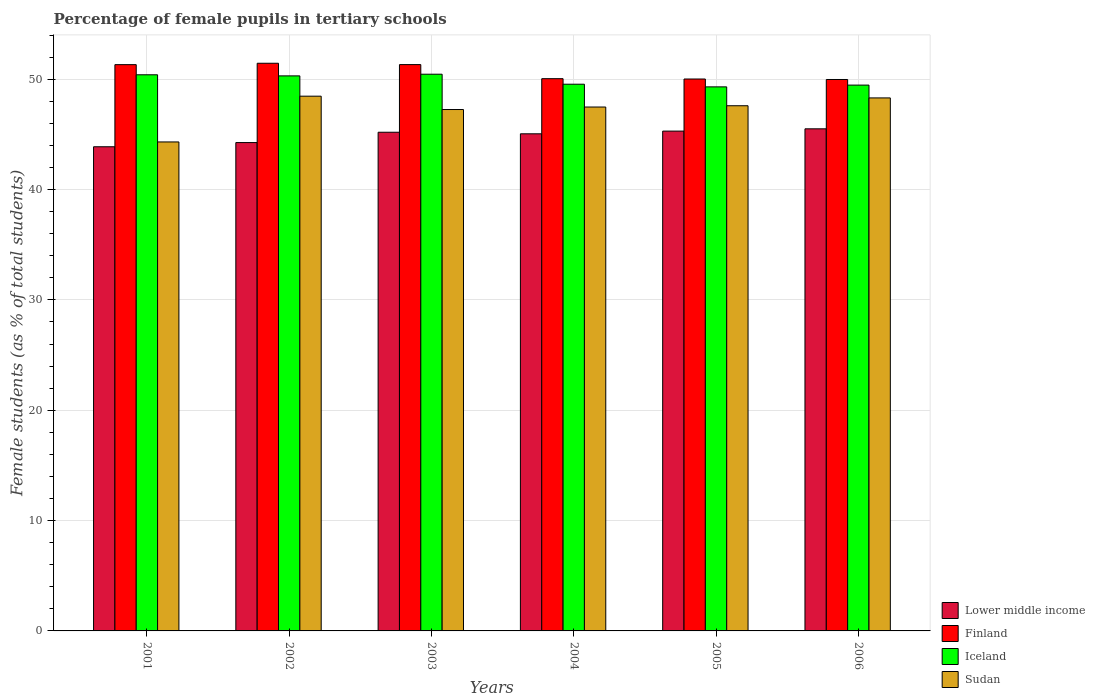How many different coloured bars are there?
Give a very brief answer. 4. How many groups of bars are there?
Offer a very short reply. 6. How many bars are there on the 1st tick from the right?
Make the answer very short. 4. What is the label of the 1st group of bars from the left?
Your answer should be compact. 2001. In how many cases, is the number of bars for a given year not equal to the number of legend labels?
Provide a short and direct response. 0. What is the percentage of female pupils in tertiary schools in Sudan in 2001?
Your answer should be compact. 44.31. Across all years, what is the maximum percentage of female pupils in tertiary schools in Lower middle income?
Ensure brevity in your answer.  45.5. Across all years, what is the minimum percentage of female pupils in tertiary schools in Finland?
Your answer should be very brief. 49.97. In which year was the percentage of female pupils in tertiary schools in Finland maximum?
Your response must be concise. 2002. In which year was the percentage of female pupils in tertiary schools in Lower middle income minimum?
Offer a very short reply. 2001. What is the total percentage of female pupils in tertiary schools in Iceland in the graph?
Provide a succinct answer. 299.46. What is the difference between the percentage of female pupils in tertiary schools in Finland in 2005 and that in 2006?
Give a very brief answer. 0.04. What is the difference between the percentage of female pupils in tertiary schools in Sudan in 2003 and the percentage of female pupils in tertiary schools in Lower middle income in 2005?
Make the answer very short. 1.96. What is the average percentage of female pupils in tertiary schools in Finland per year?
Your answer should be very brief. 50.69. In the year 2004, what is the difference between the percentage of female pupils in tertiary schools in Iceland and percentage of female pupils in tertiary schools in Lower middle income?
Provide a short and direct response. 4.5. In how many years, is the percentage of female pupils in tertiary schools in Sudan greater than 32 %?
Give a very brief answer. 6. What is the ratio of the percentage of female pupils in tertiary schools in Iceland in 2001 to that in 2006?
Ensure brevity in your answer.  1.02. Is the percentage of female pupils in tertiary schools in Iceland in 2001 less than that in 2004?
Provide a succinct answer. No. What is the difference between the highest and the second highest percentage of female pupils in tertiary schools in Lower middle income?
Provide a succinct answer. 0.21. What is the difference between the highest and the lowest percentage of female pupils in tertiary schools in Sudan?
Keep it short and to the point. 4.15. Is the sum of the percentage of female pupils in tertiary schools in Iceland in 2002 and 2004 greater than the maximum percentage of female pupils in tertiary schools in Finland across all years?
Your answer should be very brief. Yes. Is it the case that in every year, the sum of the percentage of female pupils in tertiary schools in Iceland and percentage of female pupils in tertiary schools in Sudan is greater than the sum of percentage of female pupils in tertiary schools in Lower middle income and percentage of female pupils in tertiary schools in Finland?
Provide a succinct answer. Yes. What does the 3rd bar from the left in 2003 represents?
Your answer should be very brief. Iceland. Are all the bars in the graph horizontal?
Give a very brief answer. No. How many years are there in the graph?
Offer a very short reply. 6. What is the difference between two consecutive major ticks on the Y-axis?
Offer a very short reply. 10. Does the graph contain any zero values?
Make the answer very short. No. Where does the legend appear in the graph?
Provide a succinct answer. Bottom right. How many legend labels are there?
Make the answer very short. 4. How are the legend labels stacked?
Make the answer very short. Vertical. What is the title of the graph?
Your answer should be very brief. Percentage of female pupils in tertiary schools. What is the label or title of the X-axis?
Your answer should be very brief. Years. What is the label or title of the Y-axis?
Provide a short and direct response. Female students (as % of total students). What is the Female students (as % of total students) of Lower middle income in 2001?
Your response must be concise. 43.87. What is the Female students (as % of total students) of Finland in 2001?
Ensure brevity in your answer.  51.32. What is the Female students (as % of total students) in Iceland in 2001?
Provide a short and direct response. 50.4. What is the Female students (as % of total students) in Sudan in 2001?
Provide a short and direct response. 44.31. What is the Female students (as % of total students) in Lower middle income in 2002?
Give a very brief answer. 44.25. What is the Female students (as % of total students) of Finland in 2002?
Provide a succinct answer. 51.44. What is the Female students (as % of total students) of Iceland in 2002?
Make the answer very short. 50.3. What is the Female students (as % of total students) in Sudan in 2002?
Your response must be concise. 48.46. What is the Female students (as % of total students) of Lower middle income in 2003?
Give a very brief answer. 45.19. What is the Female students (as % of total students) in Finland in 2003?
Give a very brief answer. 51.32. What is the Female students (as % of total students) of Iceland in 2003?
Provide a short and direct response. 50.45. What is the Female students (as % of total students) in Sudan in 2003?
Make the answer very short. 47.25. What is the Female students (as % of total students) of Lower middle income in 2004?
Provide a short and direct response. 45.05. What is the Female students (as % of total students) in Finland in 2004?
Provide a succinct answer. 50.04. What is the Female students (as % of total students) in Iceland in 2004?
Ensure brevity in your answer.  49.54. What is the Female students (as % of total students) in Sudan in 2004?
Keep it short and to the point. 47.48. What is the Female students (as % of total students) of Lower middle income in 2005?
Offer a very short reply. 45.29. What is the Female students (as % of total students) of Finland in 2005?
Offer a terse response. 50.02. What is the Female students (as % of total students) in Iceland in 2005?
Offer a very short reply. 49.3. What is the Female students (as % of total students) of Sudan in 2005?
Your answer should be very brief. 47.59. What is the Female students (as % of total students) in Lower middle income in 2006?
Your answer should be very brief. 45.5. What is the Female students (as % of total students) of Finland in 2006?
Ensure brevity in your answer.  49.97. What is the Female students (as % of total students) of Iceland in 2006?
Offer a terse response. 49.46. What is the Female students (as % of total students) of Sudan in 2006?
Your answer should be very brief. 48.3. Across all years, what is the maximum Female students (as % of total students) of Lower middle income?
Provide a short and direct response. 45.5. Across all years, what is the maximum Female students (as % of total students) in Finland?
Your response must be concise. 51.44. Across all years, what is the maximum Female students (as % of total students) of Iceland?
Provide a succinct answer. 50.45. Across all years, what is the maximum Female students (as % of total students) in Sudan?
Make the answer very short. 48.46. Across all years, what is the minimum Female students (as % of total students) of Lower middle income?
Ensure brevity in your answer.  43.87. Across all years, what is the minimum Female students (as % of total students) in Finland?
Ensure brevity in your answer.  49.97. Across all years, what is the minimum Female students (as % of total students) in Iceland?
Provide a short and direct response. 49.3. Across all years, what is the minimum Female students (as % of total students) in Sudan?
Offer a terse response. 44.31. What is the total Female students (as % of total students) in Lower middle income in the graph?
Your response must be concise. 269.17. What is the total Female students (as % of total students) of Finland in the graph?
Your answer should be very brief. 304.11. What is the total Female students (as % of total students) in Iceland in the graph?
Your response must be concise. 299.46. What is the total Female students (as % of total students) in Sudan in the graph?
Provide a short and direct response. 283.39. What is the difference between the Female students (as % of total students) in Lower middle income in 2001 and that in 2002?
Provide a succinct answer. -0.38. What is the difference between the Female students (as % of total students) of Finland in 2001 and that in 2002?
Provide a short and direct response. -0.13. What is the difference between the Female students (as % of total students) of Iceland in 2001 and that in 2002?
Ensure brevity in your answer.  0.1. What is the difference between the Female students (as % of total students) of Sudan in 2001 and that in 2002?
Ensure brevity in your answer.  -4.15. What is the difference between the Female students (as % of total students) of Lower middle income in 2001 and that in 2003?
Your answer should be very brief. -1.32. What is the difference between the Female students (as % of total students) in Finland in 2001 and that in 2003?
Your response must be concise. -0.01. What is the difference between the Female students (as % of total students) of Iceland in 2001 and that in 2003?
Ensure brevity in your answer.  -0.05. What is the difference between the Female students (as % of total students) in Sudan in 2001 and that in 2003?
Make the answer very short. -2.94. What is the difference between the Female students (as % of total students) in Lower middle income in 2001 and that in 2004?
Make the answer very short. -1.17. What is the difference between the Female students (as % of total students) in Finland in 2001 and that in 2004?
Your answer should be compact. 1.27. What is the difference between the Female students (as % of total students) in Iceland in 2001 and that in 2004?
Make the answer very short. 0.85. What is the difference between the Female students (as % of total students) of Sudan in 2001 and that in 2004?
Provide a short and direct response. -3.16. What is the difference between the Female students (as % of total students) in Lower middle income in 2001 and that in 2005?
Make the answer very short. -1.42. What is the difference between the Female students (as % of total students) in Finland in 2001 and that in 2005?
Offer a terse response. 1.3. What is the difference between the Female students (as % of total students) of Iceland in 2001 and that in 2005?
Offer a terse response. 1.1. What is the difference between the Female students (as % of total students) of Sudan in 2001 and that in 2005?
Ensure brevity in your answer.  -3.28. What is the difference between the Female students (as % of total students) of Lower middle income in 2001 and that in 2006?
Ensure brevity in your answer.  -1.63. What is the difference between the Female students (as % of total students) of Finland in 2001 and that in 2006?
Provide a short and direct response. 1.34. What is the difference between the Female students (as % of total students) of Iceland in 2001 and that in 2006?
Give a very brief answer. 0.93. What is the difference between the Female students (as % of total students) in Sudan in 2001 and that in 2006?
Provide a succinct answer. -3.99. What is the difference between the Female students (as % of total students) of Lower middle income in 2002 and that in 2003?
Keep it short and to the point. -0.94. What is the difference between the Female students (as % of total students) of Finland in 2002 and that in 2003?
Your answer should be very brief. 0.12. What is the difference between the Female students (as % of total students) in Iceland in 2002 and that in 2003?
Ensure brevity in your answer.  -0.15. What is the difference between the Female students (as % of total students) of Sudan in 2002 and that in 2003?
Your response must be concise. 1.21. What is the difference between the Female students (as % of total students) of Lower middle income in 2002 and that in 2004?
Ensure brevity in your answer.  -0.79. What is the difference between the Female students (as % of total students) of Finland in 2002 and that in 2004?
Offer a terse response. 1.4. What is the difference between the Female students (as % of total students) of Iceland in 2002 and that in 2004?
Provide a succinct answer. 0.75. What is the difference between the Female students (as % of total students) of Sudan in 2002 and that in 2004?
Provide a short and direct response. 0.98. What is the difference between the Female students (as % of total students) in Lower middle income in 2002 and that in 2005?
Offer a very short reply. -1.04. What is the difference between the Female students (as % of total students) of Finland in 2002 and that in 2005?
Give a very brief answer. 1.43. What is the difference between the Female students (as % of total students) in Sudan in 2002 and that in 2005?
Keep it short and to the point. 0.87. What is the difference between the Female students (as % of total students) in Lower middle income in 2002 and that in 2006?
Ensure brevity in your answer.  -1.25. What is the difference between the Female students (as % of total students) in Finland in 2002 and that in 2006?
Provide a short and direct response. 1.47. What is the difference between the Female students (as % of total students) of Iceland in 2002 and that in 2006?
Your response must be concise. 0.84. What is the difference between the Female students (as % of total students) in Sudan in 2002 and that in 2006?
Make the answer very short. 0.16. What is the difference between the Female students (as % of total students) in Lower middle income in 2003 and that in 2004?
Give a very brief answer. 0.14. What is the difference between the Female students (as % of total students) of Finland in 2003 and that in 2004?
Make the answer very short. 1.28. What is the difference between the Female students (as % of total students) in Iceland in 2003 and that in 2004?
Ensure brevity in your answer.  0.91. What is the difference between the Female students (as % of total students) of Sudan in 2003 and that in 2004?
Keep it short and to the point. -0.23. What is the difference between the Female students (as % of total students) in Lower middle income in 2003 and that in 2005?
Ensure brevity in your answer.  -0.1. What is the difference between the Female students (as % of total students) in Finland in 2003 and that in 2005?
Your answer should be compact. 1.31. What is the difference between the Female students (as % of total students) of Iceland in 2003 and that in 2005?
Give a very brief answer. 1.15. What is the difference between the Female students (as % of total students) in Sudan in 2003 and that in 2005?
Offer a terse response. -0.34. What is the difference between the Female students (as % of total students) of Lower middle income in 2003 and that in 2006?
Your response must be concise. -0.31. What is the difference between the Female students (as % of total students) in Finland in 2003 and that in 2006?
Give a very brief answer. 1.35. What is the difference between the Female students (as % of total students) of Iceland in 2003 and that in 2006?
Ensure brevity in your answer.  0.99. What is the difference between the Female students (as % of total students) in Sudan in 2003 and that in 2006?
Provide a succinct answer. -1.05. What is the difference between the Female students (as % of total students) of Lower middle income in 2004 and that in 2005?
Your answer should be compact. -0.25. What is the difference between the Female students (as % of total students) of Finland in 2004 and that in 2005?
Your answer should be very brief. 0.03. What is the difference between the Female students (as % of total students) in Iceland in 2004 and that in 2005?
Offer a very short reply. 0.24. What is the difference between the Female students (as % of total students) of Sudan in 2004 and that in 2005?
Offer a terse response. -0.12. What is the difference between the Female students (as % of total students) of Lower middle income in 2004 and that in 2006?
Offer a terse response. -0.45. What is the difference between the Female students (as % of total students) in Finland in 2004 and that in 2006?
Your answer should be very brief. 0.07. What is the difference between the Female students (as % of total students) of Iceland in 2004 and that in 2006?
Provide a short and direct response. 0.08. What is the difference between the Female students (as % of total students) of Sudan in 2004 and that in 2006?
Your answer should be very brief. -0.83. What is the difference between the Female students (as % of total students) in Lower middle income in 2005 and that in 2006?
Your answer should be very brief. -0.21. What is the difference between the Female students (as % of total students) in Finland in 2005 and that in 2006?
Your answer should be compact. 0.04. What is the difference between the Female students (as % of total students) in Iceland in 2005 and that in 2006?
Your answer should be compact. -0.16. What is the difference between the Female students (as % of total students) in Sudan in 2005 and that in 2006?
Make the answer very short. -0.71. What is the difference between the Female students (as % of total students) of Lower middle income in 2001 and the Female students (as % of total students) of Finland in 2002?
Give a very brief answer. -7.57. What is the difference between the Female students (as % of total students) of Lower middle income in 2001 and the Female students (as % of total students) of Iceland in 2002?
Provide a short and direct response. -6.42. What is the difference between the Female students (as % of total students) of Lower middle income in 2001 and the Female students (as % of total students) of Sudan in 2002?
Provide a short and direct response. -4.58. What is the difference between the Female students (as % of total students) in Finland in 2001 and the Female students (as % of total students) in Iceland in 2002?
Make the answer very short. 1.02. What is the difference between the Female students (as % of total students) of Finland in 2001 and the Female students (as % of total students) of Sudan in 2002?
Your answer should be very brief. 2.86. What is the difference between the Female students (as % of total students) in Iceland in 2001 and the Female students (as % of total students) in Sudan in 2002?
Your answer should be compact. 1.94. What is the difference between the Female students (as % of total students) in Lower middle income in 2001 and the Female students (as % of total students) in Finland in 2003?
Ensure brevity in your answer.  -7.45. What is the difference between the Female students (as % of total students) of Lower middle income in 2001 and the Female students (as % of total students) of Iceland in 2003?
Give a very brief answer. -6.57. What is the difference between the Female students (as % of total students) in Lower middle income in 2001 and the Female students (as % of total students) in Sudan in 2003?
Provide a succinct answer. -3.37. What is the difference between the Female students (as % of total students) in Finland in 2001 and the Female students (as % of total students) in Iceland in 2003?
Ensure brevity in your answer.  0.87. What is the difference between the Female students (as % of total students) in Finland in 2001 and the Female students (as % of total students) in Sudan in 2003?
Offer a very short reply. 4.07. What is the difference between the Female students (as % of total students) in Iceland in 2001 and the Female students (as % of total students) in Sudan in 2003?
Your answer should be compact. 3.15. What is the difference between the Female students (as % of total students) in Lower middle income in 2001 and the Female students (as % of total students) in Finland in 2004?
Provide a short and direct response. -6.17. What is the difference between the Female students (as % of total students) of Lower middle income in 2001 and the Female students (as % of total students) of Iceland in 2004?
Your response must be concise. -5.67. What is the difference between the Female students (as % of total students) in Lower middle income in 2001 and the Female students (as % of total students) in Sudan in 2004?
Your answer should be compact. -3.6. What is the difference between the Female students (as % of total students) of Finland in 2001 and the Female students (as % of total students) of Iceland in 2004?
Keep it short and to the point. 1.77. What is the difference between the Female students (as % of total students) in Finland in 2001 and the Female students (as % of total students) in Sudan in 2004?
Keep it short and to the point. 3.84. What is the difference between the Female students (as % of total students) of Iceland in 2001 and the Female students (as % of total students) of Sudan in 2004?
Your response must be concise. 2.92. What is the difference between the Female students (as % of total students) in Lower middle income in 2001 and the Female students (as % of total students) in Finland in 2005?
Offer a very short reply. -6.14. What is the difference between the Female students (as % of total students) in Lower middle income in 2001 and the Female students (as % of total students) in Iceland in 2005?
Keep it short and to the point. -5.43. What is the difference between the Female students (as % of total students) of Lower middle income in 2001 and the Female students (as % of total students) of Sudan in 2005?
Provide a short and direct response. -3.72. What is the difference between the Female students (as % of total students) of Finland in 2001 and the Female students (as % of total students) of Iceland in 2005?
Provide a succinct answer. 2.01. What is the difference between the Female students (as % of total students) in Finland in 2001 and the Female students (as % of total students) in Sudan in 2005?
Ensure brevity in your answer.  3.72. What is the difference between the Female students (as % of total students) of Iceland in 2001 and the Female students (as % of total students) of Sudan in 2005?
Ensure brevity in your answer.  2.81. What is the difference between the Female students (as % of total students) in Lower middle income in 2001 and the Female students (as % of total students) in Finland in 2006?
Offer a very short reply. -6.1. What is the difference between the Female students (as % of total students) in Lower middle income in 2001 and the Female students (as % of total students) in Iceland in 2006?
Ensure brevity in your answer.  -5.59. What is the difference between the Female students (as % of total students) of Lower middle income in 2001 and the Female students (as % of total students) of Sudan in 2006?
Make the answer very short. -4.43. What is the difference between the Female students (as % of total students) of Finland in 2001 and the Female students (as % of total students) of Iceland in 2006?
Your answer should be compact. 1.85. What is the difference between the Female students (as % of total students) of Finland in 2001 and the Female students (as % of total students) of Sudan in 2006?
Your answer should be very brief. 3.01. What is the difference between the Female students (as % of total students) in Iceland in 2001 and the Female students (as % of total students) in Sudan in 2006?
Your response must be concise. 2.1. What is the difference between the Female students (as % of total students) of Lower middle income in 2002 and the Female students (as % of total students) of Finland in 2003?
Make the answer very short. -7.07. What is the difference between the Female students (as % of total students) in Lower middle income in 2002 and the Female students (as % of total students) in Iceland in 2003?
Provide a short and direct response. -6.19. What is the difference between the Female students (as % of total students) in Lower middle income in 2002 and the Female students (as % of total students) in Sudan in 2003?
Give a very brief answer. -2.99. What is the difference between the Female students (as % of total students) of Finland in 2002 and the Female students (as % of total students) of Sudan in 2003?
Ensure brevity in your answer.  4.19. What is the difference between the Female students (as % of total students) in Iceland in 2002 and the Female students (as % of total students) in Sudan in 2003?
Your answer should be very brief. 3.05. What is the difference between the Female students (as % of total students) of Lower middle income in 2002 and the Female students (as % of total students) of Finland in 2004?
Give a very brief answer. -5.79. What is the difference between the Female students (as % of total students) of Lower middle income in 2002 and the Female students (as % of total students) of Iceland in 2004?
Offer a terse response. -5.29. What is the difference between the Female students (as % of total students) in Lower middle income in 2002 and the Female students (as % of total students) in Sudan in 2004?
Provide a short and direct response. -3.22. What is the difference between the Female students (as % of total students) in Finland in 2002 and the Female students (as % of total students) in Iceland in 2004?
Provide a succinct answer. 1.9. What is the difference between the Female students (as % of total students) in Finland in 2002 and the Female students (as % of total students) in Sudan in 2004?
Provide a succinct answer. 3.97. What is the difference between the Female students (as % of total students) of Iceland in 2002 and the Female students (as % of total students) of Sudan in 2004?
Offer a very short reply. 2.82. What is the difference between the Female students (as % of total students) of Lower middle income in 2002 and the Female students (as % of total students) of Finland in 2005?
Your answer should be compact. -5.76. What is the difference between the Female students (as % of total students) of Lower middle income in 2002 and the Female students (as % of total students) of Iceland in 2005?
Offer a very short reply. -5.05. What is the difference between the Female students (as % of total students) of Lower middle income in 2002 and the Female students (as % of total students) of Sudan in 2005?
Provide a succinct answer. -3.34. What is the difference between the Female students (as % of total students) of Finland in 2002 and the Female students (as % of total students) of Iceland in 2005?
Give a very brief answer. 2.14. What is the difference between the Female students (as % of total students) of Finland in 2002 and the Female students (as % of total students) of Sudan in 2005?
Your answer should be very brief. 3.85. What is the difference between the Female students (as % of total students) of Iceland in 2002 and the Female students (as % of total students) of Sudan in 2005?
Ensure brevity in your answer.  2.71. What is the difference between the Female students (as % of total students) of Lower middle income in 2002 and the Female students (as % of total students) of Finland in 2006?
Offer a terse response. -5.72. What is the difference between the Female students (as % of total students) of Lower middle income in 2002 and the Female students (as % of total students) of Iceland in 2006?
Provide a succinct answer. -5.21. What is the difference between the Female students (as % of total students) of Lower middle income in 2002 and the Female students (as % of total students) of Sudan in 2006?
Provide a short and direct response. -4.05. What is the difference between the Female students (as % of total students) in Finland in 2002 and the Female students (as % of total students) in Iceland in 2006?
Provide a short and direct response. 1.98. What is the difference between the Female students (as % of total students) in Finland in 2002 and the Female students (as % of total students) in Sudan in 2006?
Offer a terse response. 3.14. What is the difference between the Female students (as % of total students) of Iceland in 2002 and the Female students (as % of total students) of Sudan in 2006?
Offer a very short reply. 2. What is the difference between the Female students (as % of total students) in Lower middle income in 2003 and the Female students (as % of total students) in Finland in 2004?
Ensure brevity in your answer.  -4.85. What is the difference between the Female students (as % of total students) of Lower middle income in 2003 and the Female students (as % of total students) of Iceland in 2004?
Your answer should be very brief. -4.35. What is the difference between the Female students (as % of total students) in Lower middle income in 2003 and the Female students (as % of total students) in Sudan in 2004?
Ensure brevity in your answer.  -2.29. What is the difference between the Female students (as % of total students) in Finland in 2003 and the Female students (as % of total students) in Iceland in 2004?
Offer a terse response. 1.78. What is the difference between the Female students (as % of total students) of Finland in 2003 and the Female students (as % of total students) of Sudan in 2004?
Offer a terse response. 3.85. What is the difference between the Female students (as % of total students) of Iceland in 2003 and the Female students (as % of total students) of Sudan in 2004?
Offer a terse response. 2.97. What is the difference between the Female students (as % of total students) of Lower middle income in 2003 and the Female students (as % of total students) of Finland in 2005?
Keep it short and to the point. -4.82. What is the difference between the Female students (as % of total students) of Lower middle income in 2003 and the Female students (as % of total students) of Iceland in 2005?
Offer a terse response. -4.11. What is the difference between the Female students (as % of total students) in Lower middle income in 2003 and the Female students (as % of total students) in Sudan in 2005?
Your answer should be very brief. -2.4. What is the difference between the Female students (as % of total students) of Finland in 2003 and the Female students (as % of total students) of Iceland in 2005?
Ensure brevity in your answer.  2.02. What is the difference between the Female students (as % of total students) in Finland in 2003 and the Female students (as % of total students) in Sudan in 2005?
Your answer should be compact. 3.73. What is the difference between the Female students (as % of total students) of Iceland in 2003 and the Female students (as % of total students) of Sudan in 2005?
Keep it short and to the point. 2.86. What is the difference between the Female students (as % of total students) in Lower middle income in 2003 and the Female students (as % of total students) in Finland in 2006?
Ensure brevity in your answer.  -4.78. What is the difference between the Female students (as % of total students) of Lower middle income in 2003 and the Female students (as % of total students) of Iceland in 2006?
Provide a succinct answer. -4.27. What is the difference between the Female students (as % of total students) of Lower middle income in 2003 and the Female students (as % of total students) of Sudan in 2006?
Your response must be concise. -3.11. What is the difference between the Female students (as % of total students) in Finland in 2003 and the Female students (as % of total students) in Iceland in 2006?
Your answer should be compact. 1.86. What is the difference between the Female students (as % of total students) of Finland in 2003 and the Female students (as % of total students) of Sudan in 2006?
Offer a very short reply. 3.02. What is the difference between the Female students (as % of total students) of Iceland in 2003 and the Female students (as % of total students) of Sudan in 2006?
Your answer should be very brief. 2.15. What is the difference between the Female students (as % of total students) of Lower middle income in 2004 and the Female students (as % of total students) of Finland in 2005?
Keep it short and to the point. -4.97. What is the difference between the Female students (as % of total students) of Lower middle income in 2004 and the Female students (as % of total students) of Iceland in 2005?
Give a very brief answer. -4.25. What is the difference between the Female students (as % of total students) in Lower middle income in 2004 and the Female students (as % of total students) in Sudan in 2005?
Offer a terse response. -2.54. What is the difference between the Female students (as % of total students) in Finland in 2004 and the Female students (as % of total students) in Iceland in 2005?
Your response must be concise. 0.74. What is the difference between the Female students (as % of total students) in Finland in 2004 and the Female students (as % of total students) in Sudan in 2005?
Give a very brief answer. 2.45. What is the difference between the Female students (as % of total students) of Iceland in 2004 and the Female students (as % of total students) of Sudan in 2005?
Keep it short and to the point. 1.95. What is the difference between the Female students (as % of total students) of Lower middle income in 2004 and the Female students (as % of total students) of Finland in 2006?
Make the answer very short. -4.92. What is the difference between the Female students (as % of total students) in Lower middle income in 2004 and the Female students (as % of total students) in Iceland in 2006?
Your answer should be compact. -4.41. What is the difference between the Female students (as % of total students) in Lower middle income in 2004 and the Female students (as % of total students) in Sudan in 2006?
Your answer should be compact. -3.25. What is the difference between the Female students (as % of total students) of Finland in 2004 and the Female students (as % of total students) of Iceland in 2006?
Provide a short and direct response. 0.58. What is the difference between the Female students (as % of total students) in Finland in 2004 and the Female students (as % of total students) in Sudan in 2006?
Your answer should be compact. 1.74. What is the difference between the Female students (as % of total students) in Iceland in 2004 and the Female students (as % of total students) in Sudan in 2006?
Offer a very short reply. 1.24. What is the difference between the Female students (as % of total students) in Lower middle income in 2005 and the Female students (as % of total students) in Finland in 2006?
Give a very brief answer. -4.68. What is the difference between the Female students (as % of total students) in Lower middle income in 2005 and the Female students (as % of total students) in Iceland in 2006?
Ensure brevity in your answer.  -4.17. What is the difference between the Female students (as % of total students) of Lower middle income in 2005 and the Female students (as % of total students) of Sudan in 2006?
Offer a terse response. -3.01. What is the difference between the Female students (as % of total students) of Finland in 2005 and the Female students (as % of total students) of Iceland in 2006?
Your answer should be compact. 0.55. What is the difference between the Female students (as % of total students) in Finland in 2005 and the Female students (as % of total students) in Sudan in 2006?
Provide a succinct answer. 1.71. What is the average Female students (as % of total students) of Lower middle income per year?
Offer a very short reply. 44.86. What is the average Female students (as % of total students) of Finland per year?
Your response must be concise. 50.69. What is the average Female students (as % of total students) in Iceland per year?
Keep it short and to the point. 49.91. What is the average Female students (as % of total students) of Sudan per year?
Make the answer very short. 47.23. In the year 2001, what is the difference between the Female students (as % of total students) of Lower middle income and Female students (as % of total students) of Finland?
Your answer should be compact. -7.44. In the year 2001, what is the difference between the Female students (as % of total students) of Lower middle income and Female students (as % of total students) of Iceland?
Give a very brief answer. -6.52. In the year 2001, what is the difference between the Female students (as % of total students) of Lower middle income and Female students (as % of total students) of Sudan?
Provide a succinct answer. -0.44. In the year 2001, what is the difference between the Female students (as % of total students) of Finland and Female students (as % of total students) of Iceland?
Give a very brief answer. 0.92. In the year 2001, what is the difference between the Female students (as % of total students) of Finland and Female students (as % of total students) of Sudan?
Your answer should be very brief. 7. In the year 2001, what is the difference between the Female students (as % of total students) of Iceland and Female students (as % of total students) of Sudan?
Offer a terse response. 6.09. In the year 2002, what is the difference between the Female students (as % of total students) in Lower middle income and Female students (as % of total students) in Finland?
Keep it short and to the point. -7.19. In the year 2002, what is the difference between the Female students (as % of total students) in Lower middle income and Female students (as % of total students) in Iceland?
Your answer should be compact. -6.04. In the year 2002, what is the difference between the Female students (as % of total students) of Lower middle income and Female students (as % of total students) of Sudan?
Make the answer very short. -4.2. In the year 2002, what is the difference between the Female students (as % of total students) in Finland and Female students (as % of total students) in Iceland?
Provide a succinct answer. 1.14. In the year 2002, what is the difference between the Female students (as % of total students) in Finland and Female students (as % of total students) in Sudan?
Your response must be concise. 2.98. In the year 2002, what is the difference between the Female students (as % of total students) in Iceland and Female students (as % of total students) in Sudan?
Keep it short and to the point. 1.84. In the year 2003, what is the difference between the Female students (as % of total students) in Lower middle income and Female students (as % of total students) in Finland?
Provide a succinct answer. -6.13. In the year 2003, what is the difference between the Female students (as % of total students) of Lower middle income and Female students (as % of total students) of Iceland?
Give a very brief answer. -5.26. In the year 2003, what is the difference between the Female students (as % of total students) of Lower middle income and Female students (as % of total students) of Sudan?
Ensure brevity in your answer.  -2.06. In the year 2003, what is the difference between the Female students (as % of total students) in Finland and Female students (as % of total students) in Iceland?
Make the answer very short. 0.87. In the year 2003, what is the difference between the Female students (as % of total students) of Finland and Female students (as % of total students) of Sudan?
Your answer should be very brief. 4.07. In the year 2003, what is the difference between the Female students (as % of total students) in Iceland and Female students (as % of total students) in Sudan?
Offer a terse response. 3.2. In the year 2004, what is the difference between the Female students (as % of total students) in Lower middle income and Female students (as % of total students) in Finland?
Give a very brief answer. -5. In the year 2004, what is the difference between the Female students (as % of total students) of Lower middle income and Female students (as % of total students) of Iceland?
Ensure brevity in your answer.  -4.5. In the year 2004, what is the difference between the Female students (as % of total students) in Lower middle income and Female students (as % of total students) in Sudan?
Your answer should be compact. -2.43. In the year 2004, what is the difference between the Female students (as % of total students) of Finland and Female students (as % of total students) of Iceland?
Offer a very short reply. 0.5. In the year 2004, what is the difference between the Female students (as % of total students) of Finland and Female students (as % of total students) of Sudan?
Your response must be concise. 2.57. In the year 2004, what is the difference between the Female students (as % of total students) of Iceland and Female students (as % of total students) of Sudan?
Give a very brief answer. 2.07. In the year 2005, what is the difference between the Female students (as % of total students) of Lower middle income and Female students (as % of total students) of Finland?
Provide a short and direct response. -4.72. In the year 2005, what is the difference between the Female students (as % of total students) in Lower middle income and Female students (as % of total students) in Iceland?
Provide a succinct answer. -4.01. In the year 2005, what is the difference between the Female students (as % of total students) of Lower middle income and Female students (as % of total students) of Sudan?
Offer a very short reply. -2.3. In the year 2005, what is the difference between the Female students (as % of total students) of Finland and Female students (as % of total students) of Iceland?
Your answer should be compact. 0.71. In the year 2005, what is the difference between the Female students (as % of total students) of Finland and Female students (as % of total students) of Sudan?
Your response must be concise. 2.42. In the year 2005, what is the difference between the Female students (as % of total students) of Iceland and Female students (as % of total students) of Sudan?
Your answer should be very brief. 1.71. In the year 2006, what is the difference between the Female students (as % of total students) in Lower middle income and Female students (as % of total students) in Finland?
Your answer should be very brief. -4.47. In the year 2006, what is the difference between the Female students (as % of total students) in Lower middle income and Female students (as % of total students) in Iceland?
Offer a very short reply. -3.96. In the year 2006, what is the difference between the Female students (as % of total students) of Lower middle income and Female students (as % of total students) of Sudan?
Give a very brief answer. -2.8. In the year 2006, what is the difference between the Female students (as % of total students) in Finland and Female students (as % of total students) in Iceland?
Your response must be concise. 0.51. In the year 2006, what is the difference between the Female students (as % of total students) of Finland and Female students (as % of total students) of Sudan?
Your answer should be very brief. 1.67. In the year 2006, what is the difference between the Female students (as % of total students) of Iceland and Female students (as % of total students) of Sudan?
Make the answer very short. 1.16. What is the ratio of the Female students (as % of total students) in Sudan in 2001 to that in 2002?
Offer a very short reply. 0.91. What is the ratio of the Female students (as % of total students) in Lower middle income in 2001 to that in 2003?
Provide a short and direct response. 0.97. What is the ratio of the Female students (as % of total students) in Finland in 2001 to that in 2003?
Provide a succinct answer. 1. What is the ratio of the Female students (as % of total students) in Sudan in 2001 to that in 2003?
Your answer should be compact. 0.94. What is the ratio of the Female students (as % of total students) of Lower middle income in 2001 to that in 2004?
Your answer should be compact. 0.97. What is the ratio of the Female students (as % of total students) of Finland in 2001 to that in 2004?
Offer a terse response. 1.03. What is the ratio of the Female students (as % of total students) of Iceland in 2001 to that in 2004?
Make the answer very short. 1.02. What is the ratio of the Female students (as % of total students) of Sudan in 2001 to that in 2004?
Ensure brevity in your answer.  0.93. What is the ratio of the Female students (as % of total students) of Lower middle income in 2001 to that in 2005?
Offer a terse response. 0.97. What is the ratio of the Female students (as % of total students) of Finland in 2001 to that in 2005?
Offer a terse response. 1.03. What is the ratio of the Female students (as % of total students) in Iceland in 2001 to that in 2005?
Ensure brevity in your answer.  1.02. What is the ratio of the Female students (as % of total students) in Sudan in 2001 to that in 2005?
Keep it short and to the point. 0.93. What is the ratio of the Female students (as % of total students) of Finland in 2001 to that in 2006?
Keep it short and to the point. 1.03. What is the ratio of the Female students (as % of total students) in Iceland in 2001 to that in 2006?
Your answer should be compact. 1.02. What is the ratio of the Female students (as % of total students) in Sudan in 2001 to that in 2006?
Make the answer very short. 0.92. What is the ratio of the Female students (as % of total students) in Lower middle income in 2002 to that in 2003?
Your answer should be compact. 0.98. What is the ratio of the Female students (as % of total students) of Finland in 2002 to that in 2003?
Your response must be concise. 1. What is the ratio of the Female students (as % of total students) in Sudan in 2002 to that in 2003?
Your response must be concise. 1.03. What is the ratio of the Female students (as % of total students) of Lower middle income in 2002 to that in 2004?
Give a very brief answer. 0.98. What is the ratio of the Female students (as % of total students) in Finland in 2002 to that in 2004?
Provide a short and direct response. 1.03. What is the ratio of the Female students (as % of total students) of Iceland in 2002 to that in 2004?
Ensure brevity in your answer.  1.02. What is the ratio of the Female students (as % of total students) in Sudan in 2002 to that in 2004?
Make the answer very short. 1.02. What is the ratio of the Female students (as % of total students) in Finland in 2002 to that in 2005?
Make the answer very short. 1.03. What is the ratio of the Female students (as % of total students) of Iceland in 2002 to that in 2005?
Your answer should be compact. 1.02. What is the ratio of the Female students (as % of total students) in Sudan in 2002 to that in 2005?
Make the answer very short. 1.02. What is the ratio of the Female students (as % of total students) of Lower middle income in 2002 to that in 2006?
Your answer should be very brief. 0.97. What is the ratio of the Female students (as % of total students) in Finland in 2002 to that in 2006?
Your response must be concise. 1.03. What is the ratio of the Female students (as % of total students) in Iceland in 2002 to that in 2006?
Your response must be concise. 1.02. What is the ratio of the Female students (as % of total students) in Sudan in 2002 to that in 2006?
Keep it short and to the point. 1. What is the ratio of the Female students (as % of total students) in Finland in 2003 to that in 2004?
Give a very brief answer. 1.03. What is the ratio of the Female students (as % of total students) in Iceland in 2003 to that in 2004?
Your response must be concise. 1.02. What is the ratio of the Female students (as % of total students) of Sudan in 2003 to that in 2004?
Make the answer very short. 1. What is the ratio of the Female students (as % of total students) in Finland in 2003 to that in 2005?
Give a very brief answer. 1.03. What is the ratio of the Female students (as % of total students) in Iceland in 2003 to that in 2005?
Ensure brevity in your answer.  1.02. What is the ratio of the Female students (as % of total students) of Iceland in 2003 to that in 2006?
Your answer should be very brief. 1.02. What is the ratio of the Female students (as % of total students) of Sudan in 2003 to that in 2006?
Give a very brief answer. 0.98. What is the ratio of the Female students (as % of total students) of Lower middle income in 2004 to that in 2005?
Offer a terse response. 0.99. What is the ratio of the Female students (as % of total students) in Iceland in 2004 to that in 2005?
Keep it short and to the point. 1. What is the ratio of the Female students (as % of total students) in Sudan in 2004 to that in 2005?
Provide a succinct answer. 1. What is the ratio of the Female students (as % of total students) in Lower middle income in 2004 to that in 2006?
Your answer should be very brief. 0.99. What is the ratio of the Female students (as % of total students) of Finland in 2004 to that in 2006?
Make the answer very short. 1. What is the ratio of the Female students (as % of total students) in Iceland in 2004 to that in 2006?
Provide a succinct answer. 1. What is the ratio of the Female students (as % of total students) in Sudan in 2004 to that in 2006?
Your answer should be very brief. 0.98. What is the ratio of the Female students (as % of total students) in Lower middle income in 2005 to that in 2006?
Make the answer very short. 1. What is the ratio of the Female students (as % of total students) of Sudan in 2005 to that in 2006?
Offer a very short reply. 0.99. What is the difference between the highest and the second highest Female students (as % of total students) of Lower middle income?
Give a very brief answer. 0.21. What is the difference between the highest and the second highest Female students (as % of total students) in Finland?
Your answer should be very brief. 0.12. What is the difference between the highest and the second highest Female students (as % of total students) in Iceland?
Make the answer very short. 0.05. What is the difference between the highest and the second highest Female students (as % of total students) of Sudan?
Offer a terse response. 0.16. What is the difference between the highest and the lowest Female students (as % of total students) in Lower middle income?
Provide a succinct answer. 1.63. What is the difference between the highest and the lowest Female students (as % of total students) in Finland?
Keep it short and to the point. 1.47. What is the difference between the highest and the lowest Female students (as % of total students) in Iceland?
Offer a very short reply. 1.15. What is the difference between the highest and the lowest Female students (as % of total students) of Sudan?
Ensure brevity in your answer.  4.15. 